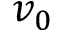<formula> <loc_0><loc_0><loc_500><loc_500>v _ { 0 }</formula> 